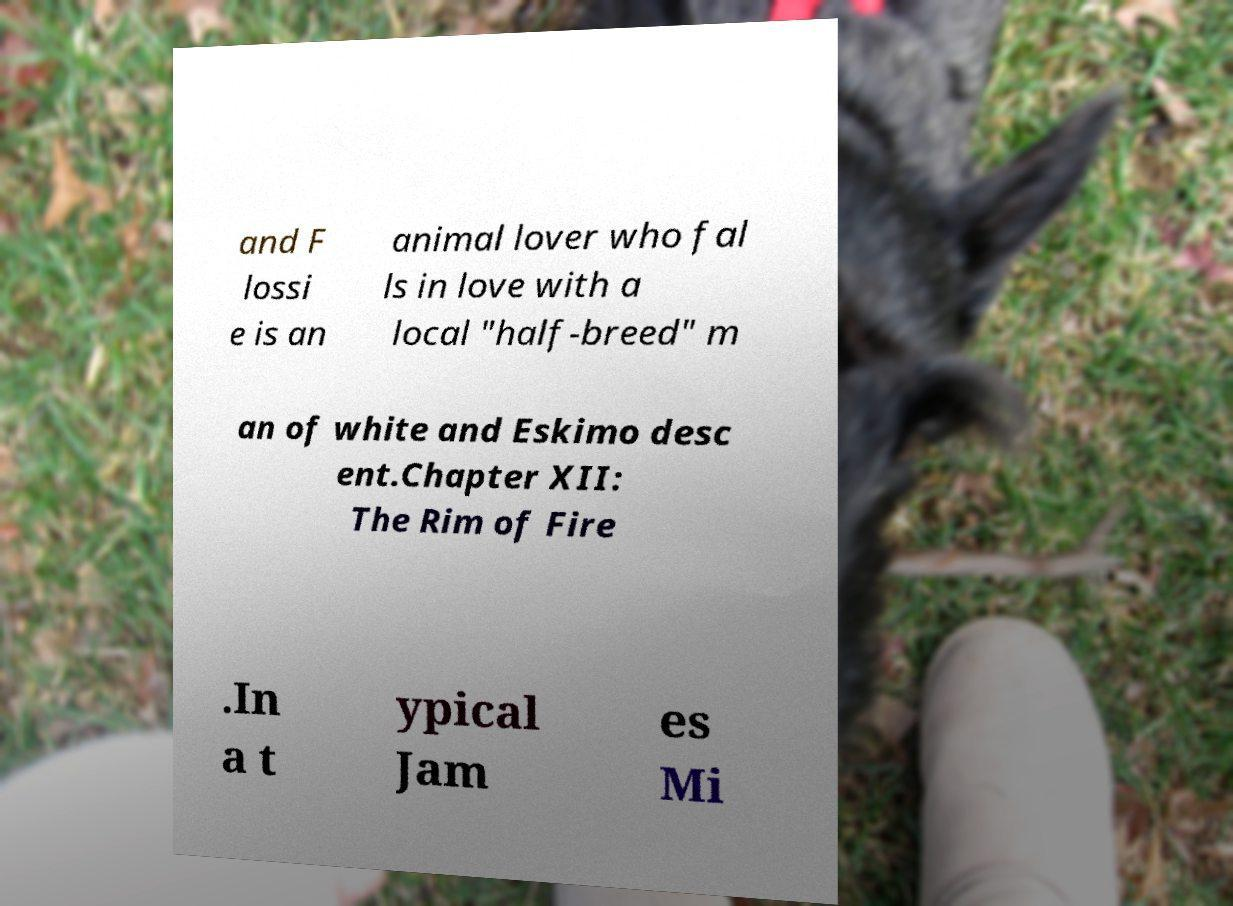For documentation purposes, I need the text within this image transcribed. Could you provide that? and F lossi e is an animal lover who fal ls in love with a local "half-breed" m an of white and Eskimo desc ent.Chapter XII: The Rim of Fire .In a t ypical Jam es Mi 